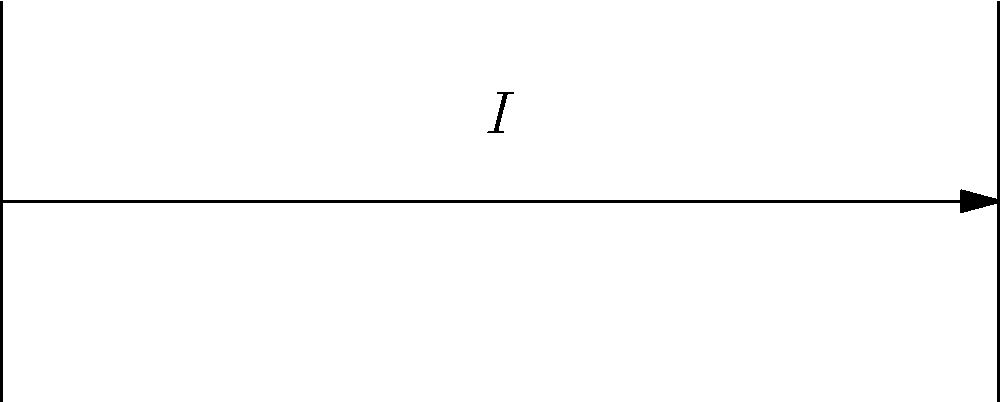In a simple DC circuit, a battery with an electromotive force of 12V is connected to a resistor with a resistance of 10Ω. Calculate the voltage drop across the resistor, considering the principles of Ohm's law and conservation of energy. To solve this problem, we'll follow these steps:

1) First, recall Ohm's law: $V = IR$, where $V$ is voltage, $I$ is current, and $R$ is resistance.

2) In a simple DC circuit with only a battery and a resistor, the voltage drop across the resistor is equal to the electromotive force of the battery due to conservation of energy.

3) Given:
   - Battery voltage: $V = 12V$
   - Resistor: $R = 10\Omega$

4) Since the voltage drop across the resistor is equal to the battery voltage:
   $V_{resistor} = 12V$

5) We can verify this using Ohm's law:
   $I = \frac{V}{R} = \frac{12V}{10\Omega} = 1.2A$

6) Then, $V_{resistor} = IR = 1.2A * 10\Omega = 12V$

Therefore, the voltage drop across the resistor is 12V, which is equal to the battery's electromotive force.
Answer: 12V 